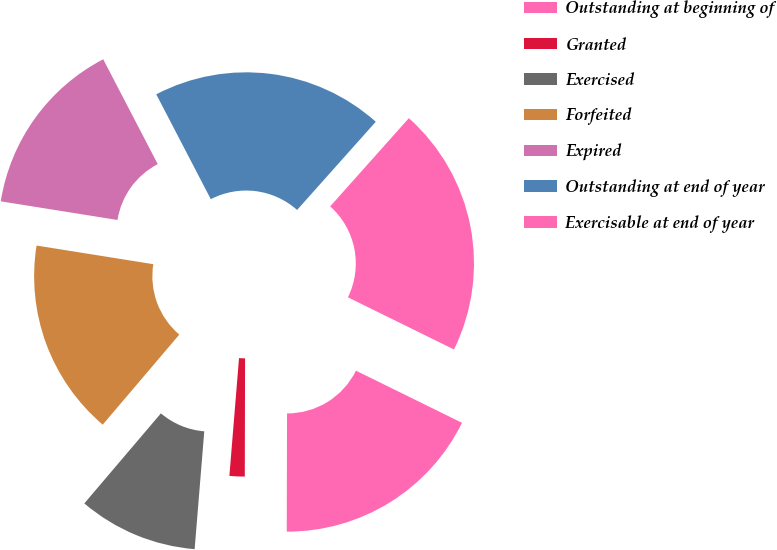<chart> <loc_0><loc_0><loc_500><loc_500><pie_chart><fcel>Outstanding at beginning of<fcel>Granted<fcel>Exercised<fcel>Forfeited<fcel>Expired<fcel>Outstanding at end of year<fcel>Exercisable at end of year<nl><fcel>17.77%<fcel>1.26%<fcel>9.92%<fcel>16.31%<fcel>14.85%<fcel>19.23%<fcel>20.69%<nl></chart> 